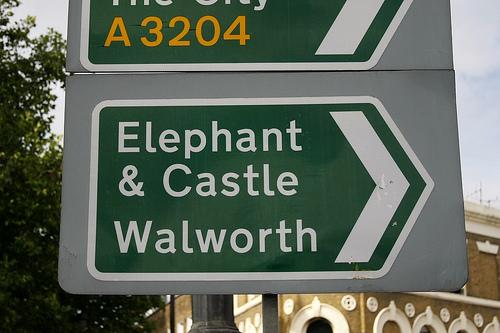Is the destination 100m away?
Be succinct. No. What animal is named in the sign?
Answer briefly. Elephant. What color is the sign?
Be succinct. Green. Which way are the arrows pointing?
Short answer required. Right. 